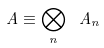Convert formula to latex. <formula><loc_0><loc_0><loc_500><loc_500>\ A \equiv \bigotimes _ { n } \ A _ { n }</formula> 